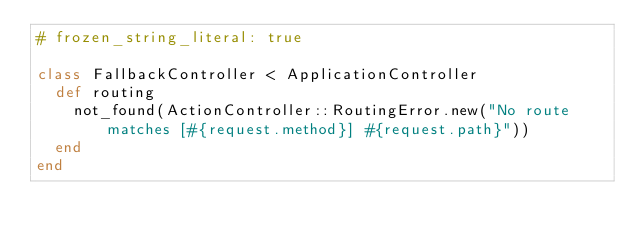Convert code to text. <code><loc_0><loc_0><loc_500><loc_500><_Ruby_># frozen_string_literal: true

class FallbackController < ApplicationController
  def routing
    not_found(ActionController::RoutingError.new("No route matches [#{request.method}] #{request.path}"))
  end
end
</code> 